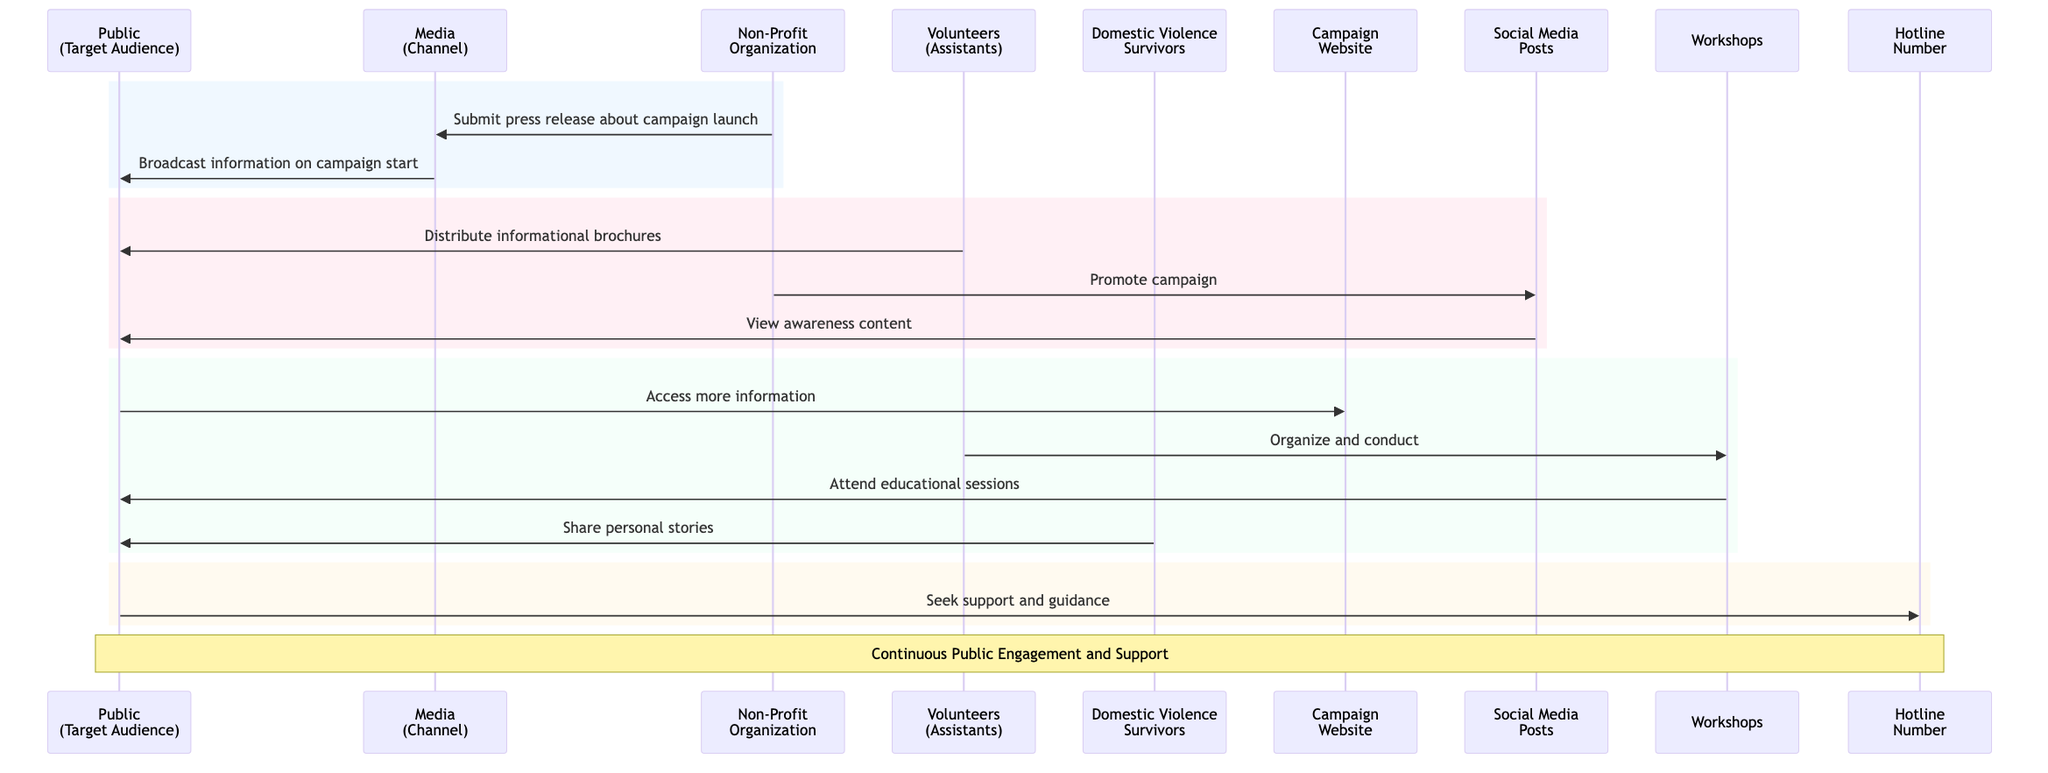What are the main actors in the diagram? The diagram lists five main actors: Public, Media, Non-Profit Organization, Volunteers, and Domestic Violence Survivors. Each actor plays a distinct role in the campaign.
Answer: Public, Media, Non-Profit Organization, Volunteers, Domestic Violence Survivors How many objects are represented in the diagram? The diagram includes five objects: Campaign Website, Social Media Posts, Workshops, Hotline Number, and Informational Brochures. The count is obtained by simply listing each unique object.
Answer: Five What action does the Non-Profit Organization take first in the diagram? The Non-Profit Organization first communicates with the Media by submitting a press release about the campaign launch. This can be seen as the initial interaction in the sequence flow.
Answer: Submit press release about campaign launch Which actor distributes informational brochures? The diagram shows that Volunteers are responsible for distributing informational brochures to the Public. This can be directly traced from the flow of messages.
Answer: Volunteers How does the Public seek support according to the diagram? The Public seeks support by communicating with the Hotline Number, as indicated in the diagram. This message flow demonstrates where the Public turns for help.
Answer: Seek support and guidance What is the relationship between Social Media Posts and the Public? Social Media Posts serve as a channel through which the Non-Profit Organization promotes the campaign, and these posts are viewed by the Public for awareness content. This describes a promotional relationship.
Answer: Promote campaign via social media posts How many distinct messages are there in total? The diagram exhibits eight distinct messages exchanged between various actors and objects, as listed in the message flow. Counting each unique interaction gives the total.
Answer: Eight What is shared during the Workshops according to Domestic Violence Survivors? Domestic Violence Survivors share personal stories during workshops and media, which emphasizes their role as advocates in educating others. This is shown in the sequence flow indicating their contribution.
Answer: Share personal stories What is the purpose of the Campaign Website in the diagram? The Campaign Website acts as a central information hub where the Public can access more information about domestic violence prevention. This is its defined role in the diagram.
Answer: Central Information Hub 